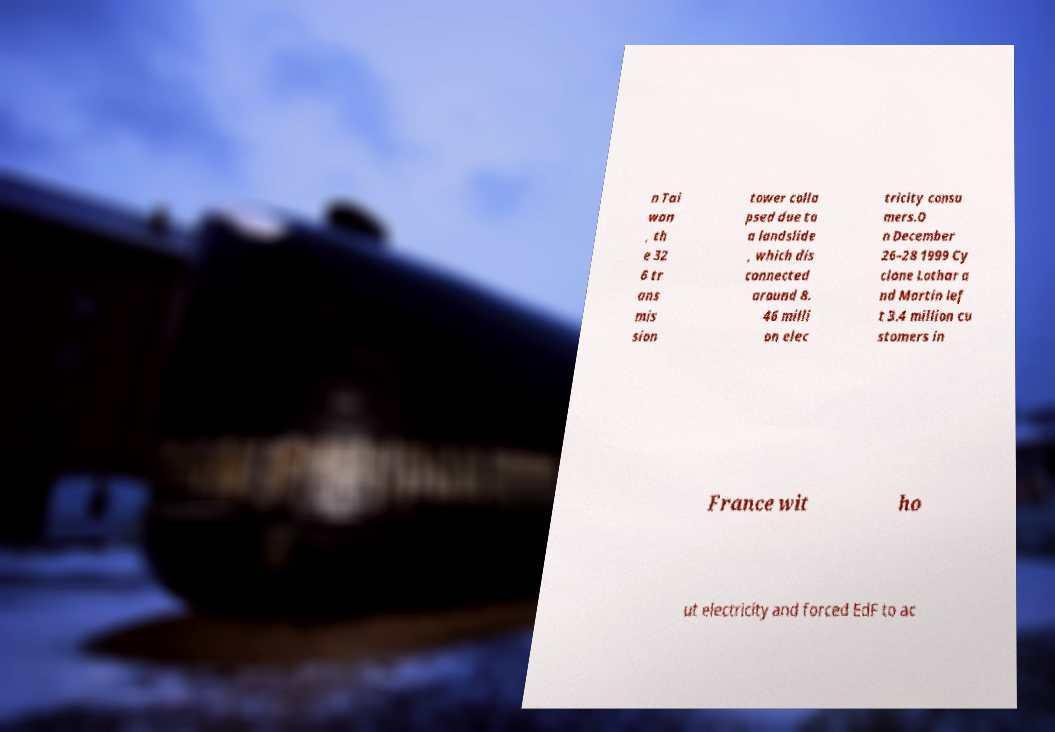For documentation purposes, I need the text within this image transcribed. Could you provide that? n Tai wan , th e 32 6 tr ans mis sion tower colla psed due to a landslide , which dis connected around 8. 46 milli on elec tricity consu mers.O n December 26–28 1999 Cy clone Lothar a nd Martin lef t 3.4 million cu stomers in France wit ho ut electricity and forced EdF to ac 